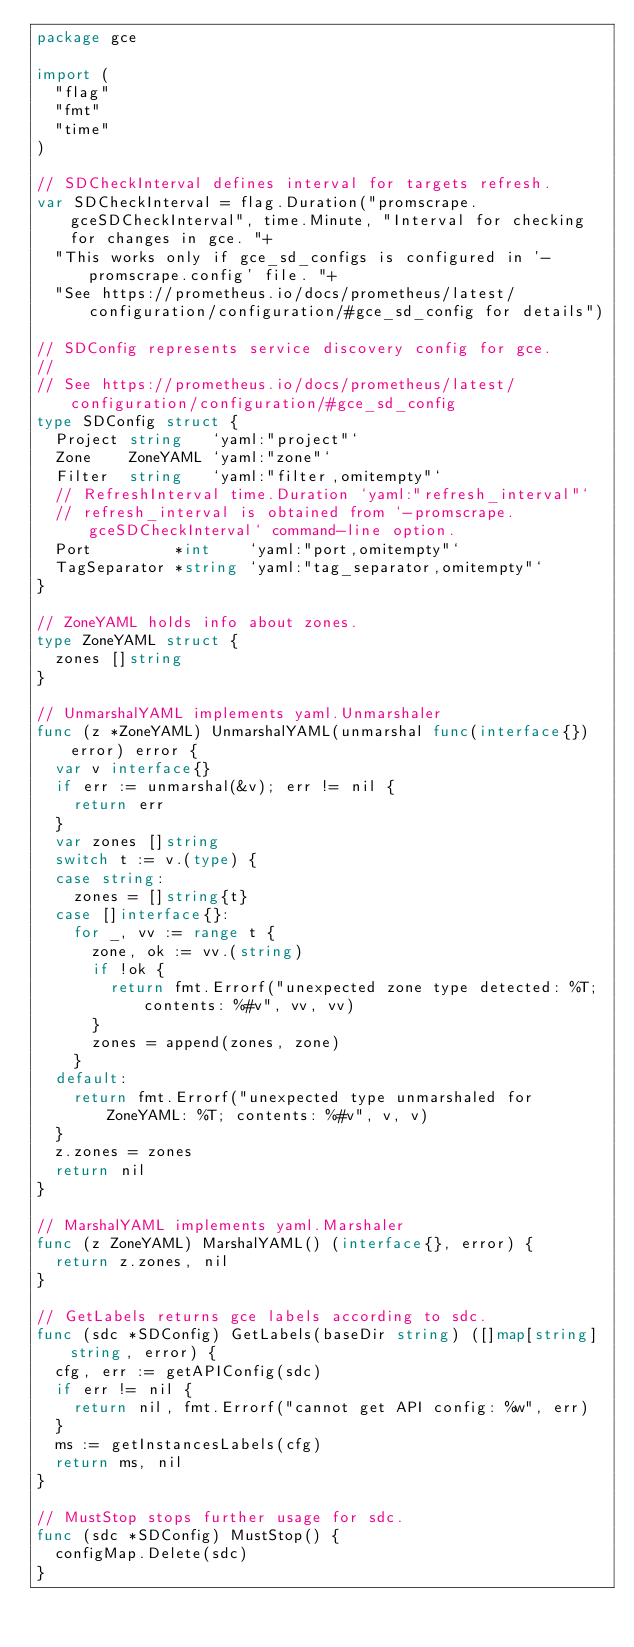Convert code to text. <code><loc_0><loc_0><loc_500><loc_500><_Go_>package gce

import (
	"flag"
	"fmt"
	"time"
)

// SDCheckInterval defines interval for targets refresh.
var SDCheckInterval = flag.Duration("promscrape.gceSDCheckInterval", time.Minute, "Interval for checking for changes in gce. "+
	"This works only if gce_sd_configs is configured in '-promscrape.config' file. "+
	"See https://prometheus.io/docs/prometheus/latest/configuration/configuration/#gce_sd_config for details")

// SDConfig represents service discovery config for gce.
//
// See https://prometheus.io/docs/prometheus/latest/configuration/configuration/#gce_sd_config
type SDConfig struct {
	Project string   `yaml:"project"`
	Zone    ZoneYAML `yaml:"zone"`
	Filter  string   `yaml:"filter,omitempty"`
	// RefreshInterval time.Duration `yaml:"refresh_interval"`
	// refresh_interval is obtained from `-promscrape.gceSDCheckInterval` command-line option.
	Port         *int    `yaml:"port,omitempty"`
	TagSeparator *string `yaml:"tag_separator,omitempty"`
}

// ZoneYAML holds info about zones.
type ZoneYAML struct {
	zones []string
}

// UnmarshalYAML implements yaml.Unmarshaler
func (z *ZoneYAML) UnmarshalYAML(unmarshal func(interface{}) error) error {
	var v interface{}
	if err := unmarshal(&v); err != nil {
		return err
	}
	var zones []string
	switch t := v.(type) {
	case string:
		zones = []string{t}
	case []interface{}:
		for _, vv := range t {
			zone, ok := vv.(string)
			if !ok {
				return fmt.Errorf("unexpected zone type detected: %T; contents: %#v", vv, vv)
			}
			zones = append(zones, zone)
		}
	default:
		return fmt.Errorf("unexpected type unmarshaled for ZoneYAML: %T; contents: %#v", v, v)
	}
	z.zones = zones
	return nil
}

// MarshalYAML implements yaml.Marshaler
func (z ZoneYAML) MarshalYAML() (interface{}, error) {
	return z.zones, nil
}

// GetLabels returns gce labels according to sdc.
func (sdc *SDConfig) GetLabels(baseDir string) ([]map[string]string, error) {
	cfg, err := getAPIConfig(sdc)
	if err != nil {
		return nil, fmt.Errorf("cannot get API config: %w", err)
	}
	ms := getInstancesLabels(cfg)
	return ms, nil
}

// MustStop stops further usage for sdc.
func (sdc *SDConfig) MustStop() {
	configMap.Delete(sdc)
}
</code> 